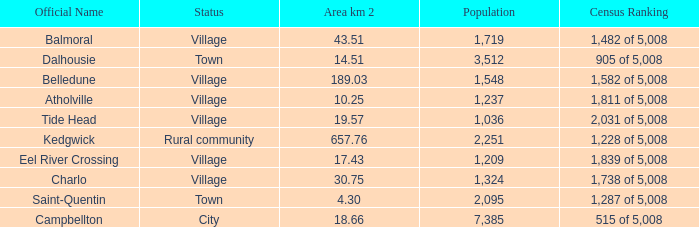When the designation is countryside community, what is the smallest region in square kilometers? 657.76. Could you parse the entire table as a dict? {'header': ['Official Name', 'Status', 'Area km 2', 'Population', 'Census Ranking'], 'rows': [['Balmoral', 'Village', '43.51', '1,719', '1,482 of 5,008'], ['Dalhousie', 'Town', '14.51', '3,512', '905 of 5,008'], ['Belledune', 'Village', '189.03', '1,548', '1,582 of 5,008'], ['Atholville', 'Village', '10.25', '1,237', '1,811 of 5,008'], ['Tide Head', 'Village', '19.57', '1,036', '2,031 of 5,008'], ['Kedgwick', 'Rural community', '657.76', '2,251', '1,228 of 5,008'], ['Eel River Crossing', 'Village', '17.43', '1,209', '1,839 of 5,008'], ['Charlo', 'Village', '30.75', '1,324', '1,738 of 5,008'], ['Saint-Quentin', 'Town', '4.30', '2,095', '1,287 of 5,008'], ['Campbellton', 'City', '18.66', '7,385', '515 of 5,008']]} 